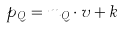Convert formula to latex. <formula><loc_0><loc_0><loc_500><loc_500>p _ { Q } = m _ { Q } \cdot v + k</formula> 